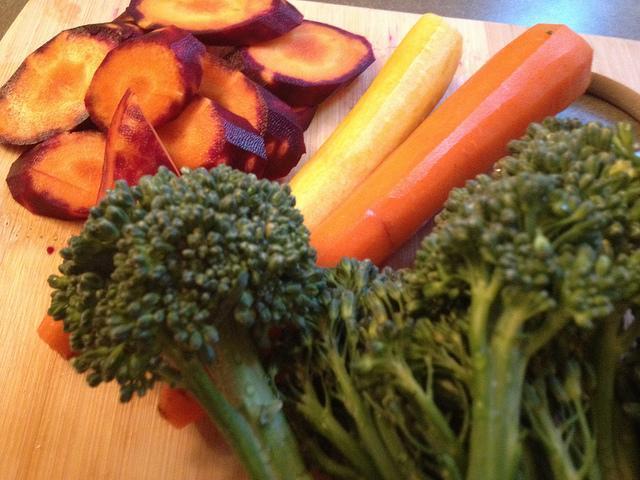How many broccolis can you see?
Give a very brief answer. 2. 